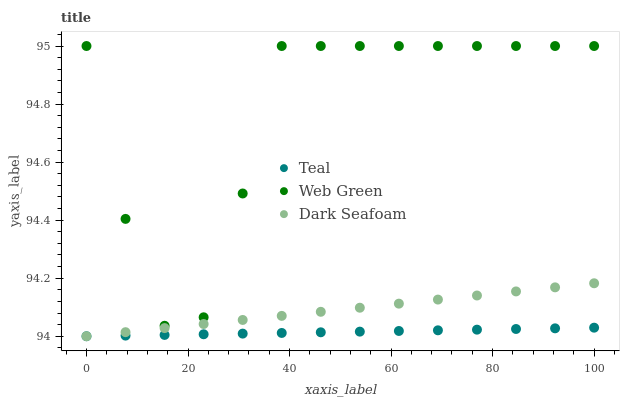Does Teal have the minimum area under the curve?
Answer yes or no. Yes. Does Web Green have the maximum area under the curve?
Answer yes or no. Yes. Does Web Green have the minimum area under the curve?
Answer yes or no. No. Does Teal have the maximum area under the curve?
Answer yes or no. No. Is Teal the smoothest?
Answer yes or no. Yes. Is Web Green the roughest?
Answer yes or no. Yes. Is Web Green the smoothest?
Answer yes or no. No. Is Teal the roughest?
Answer yes or no. No. Does Dark Seafoam have the lowest value?
Answer yes or no. Yes. Does Web Green have the lowest value?
Answer yes or no. No. Does Web Green have the highest value?
Answer yes or no. Yes. Does Teal have the highest value?
Answer yes or no. No. Is Teal less than Web Green?
Answer yes or no. Yes. Is Web Green greater than Dark Seafoam?
Answer yes or no. Yes. Does Teal intersect Dark Seafoam?
Answer yes or no. Yes. Is Teal less than Dark Seafoam?
Answer yes or no. No. Is Teal greater than Dark Seafoam?
Answer yes or no. No. Does Teal intersect Web Green?
Answer yes or no. No. 